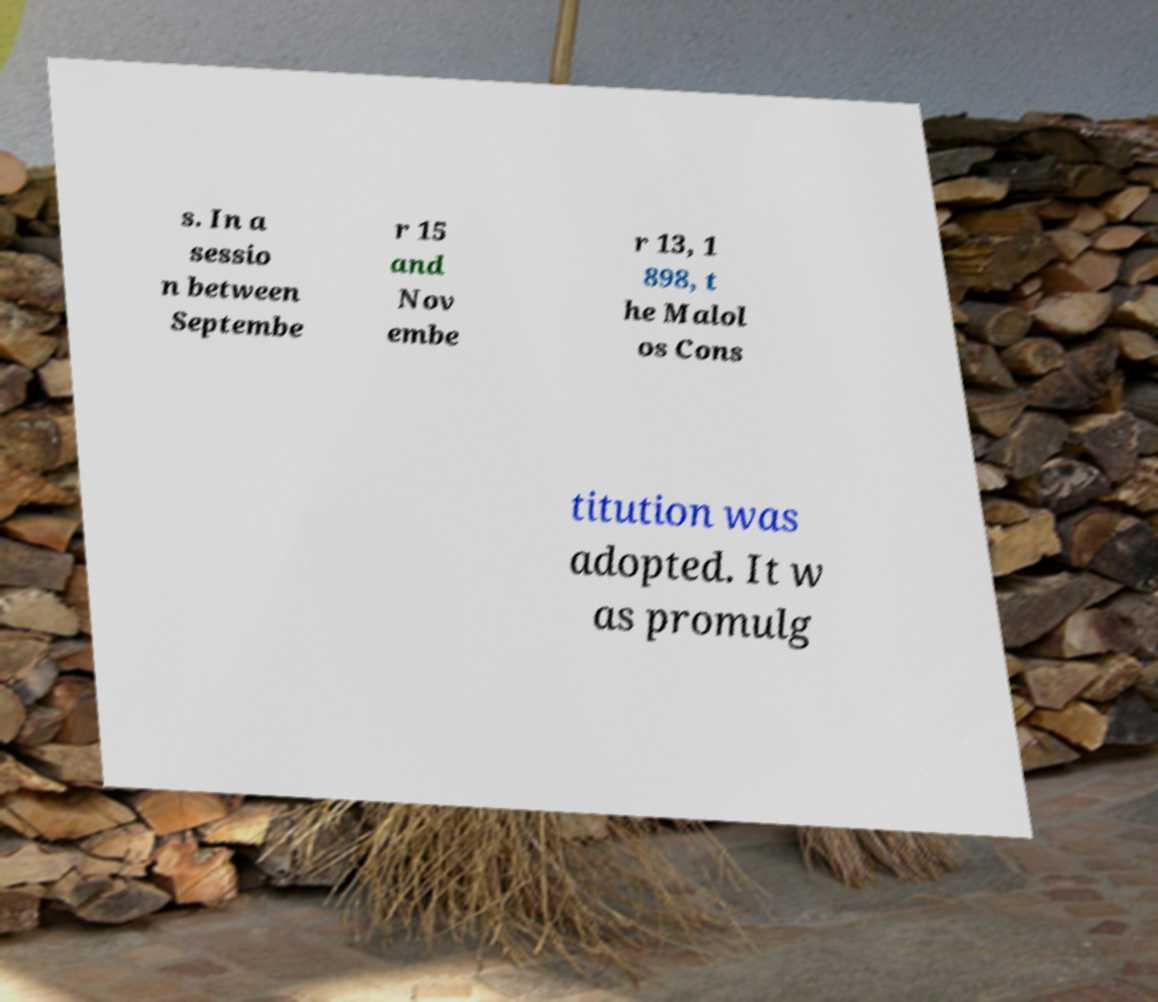Can you accurately transcribe the text from the provided image for me? s. In a sessio n between Septembe r 15 and Nov embe r 13, 1 898, t he Malol os Cons titution was adopted. It w as promulg 